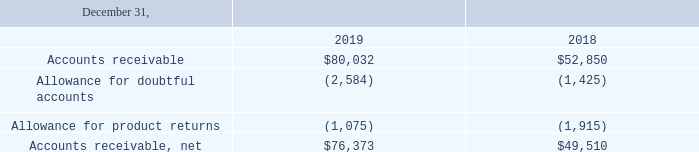Note 4. Accounts Receivable, Net
The components of accounts receivable, net are as follows (in thousands):
For the years ended December 31, 2019, 2018 and 2017, we recorded a provision for doubtful accounts of $1.2 million, $0.1 million and $0.5 million, respectively.
For the year ended December 31, 2019, we recorded a reduction to the reserve for product returns of $0.1 million. For the years ended December 31, 2018 and 2017, we recorded a $0.3 million and $2.1 million reserve for product returns in our hardware and other revenue, respectively. Historically, we have not experienced write-offs for uncollectible accounts or sales returns that have differed significantly from our estimates.
How much was the provision for doubtful accounts in 2019?
Answer scale should be: million. $1.2 million. Which years does the table provide information for accounts receivable, net for? 2019, 2018. What was the reduction to the reserve for product returns in 2019?
Answer scale should be: million. $0.1 million. What was the change in Accounts receivable between 2018 and 2019?
Answer scale should be: thousand. 80,032-52,850
Answer: 27182. How many years did net accounts receivable exceed $50,000 thousand? 2019
Answer: 1. What was the percentage change in allowance for product returns between 2018 and 2019?
Answer scale should be: percent. (-1,075+1,915)/-1,915
Answer: -43.86. 